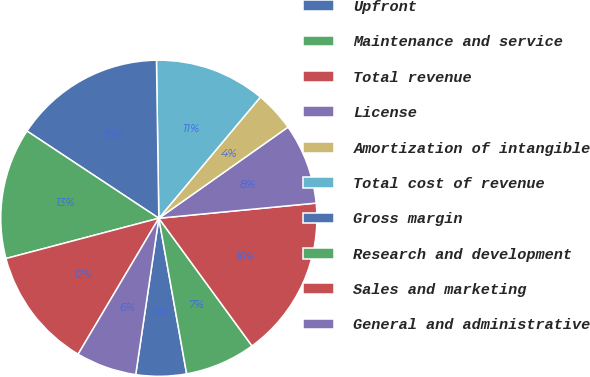<chart> <loc_0><loc_0><loc_500><loc_500><pie_chart><fcel>Upfront<fcel>Maintenance and service<fcel>Total revenue<fcel>License<fcel>Amortization of intangible<fcel>Total cost of revenue<fcel>Gross margin<fcel>Research and development<fcel>Sales and marketing<fcel>General and administrative<nl><fcel>5.15%<fcel>7.22%<fcel>16.49%<fcel>8.25%<fcel>4.12%<fcel>11.34%<fcel>15.46%<fcel>13.4%<fcel>12.37%<fcel>6.19%<nl></chart> 